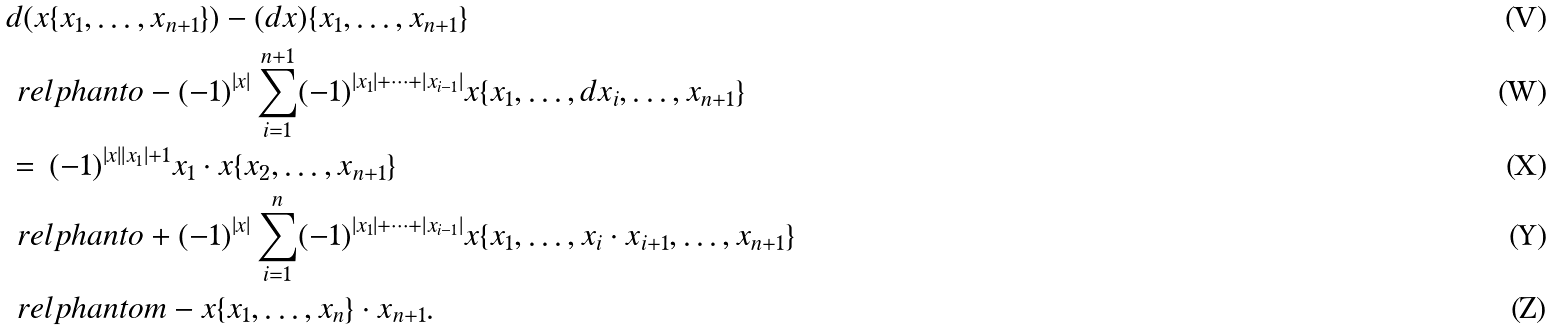Convert formula to latex. <formula><loc_0><loc_0><loc_500><loc_500>& d ( x \{ x _ { 1 } , \dots , x _ { n + 1 } \} ) - ( d x ) \{ x _ { 1 } , \dots , x _ { n + 1 } \} \\ & \ r e l p h a n t o - ( - 1 ) ^ { | x | } \sum _ { i = 1 } ^ { n + 1 } ( - 1 ) ^ { | x _ { 1 } | + \cdots + | x _ { i - 1 } | } x \{ x _ { 1 } , \dots , d x _ { i } , \dots , x _ { n + 1 } \} \\ & = \, ( - 1 ) ^ { | x | | x _ { 1 } | + 1 } x _ { 1 } \cdot x \{ x _ { 2 } , \dots , x _ { n + 1 } \} \\ & \ r e l p h a n t o + ( - 1 ) ^ { | x | } \sum _ { i = 1 } ^ { n } ( - 1 ) ^ { | x _ { 1 } | + \cdots + | x _ { i - 1 } | } x \{ x _ { 1 } , \dots , x _ { i } \cdot x _ { i + 1 } , \dots , x _ { n + 1 } \} \\ & \ r e l p h a n t o m - x \{ x _ { 1 } , \dots , x _ { n } \} \cdot x _ { n + 1 } .</formula> 